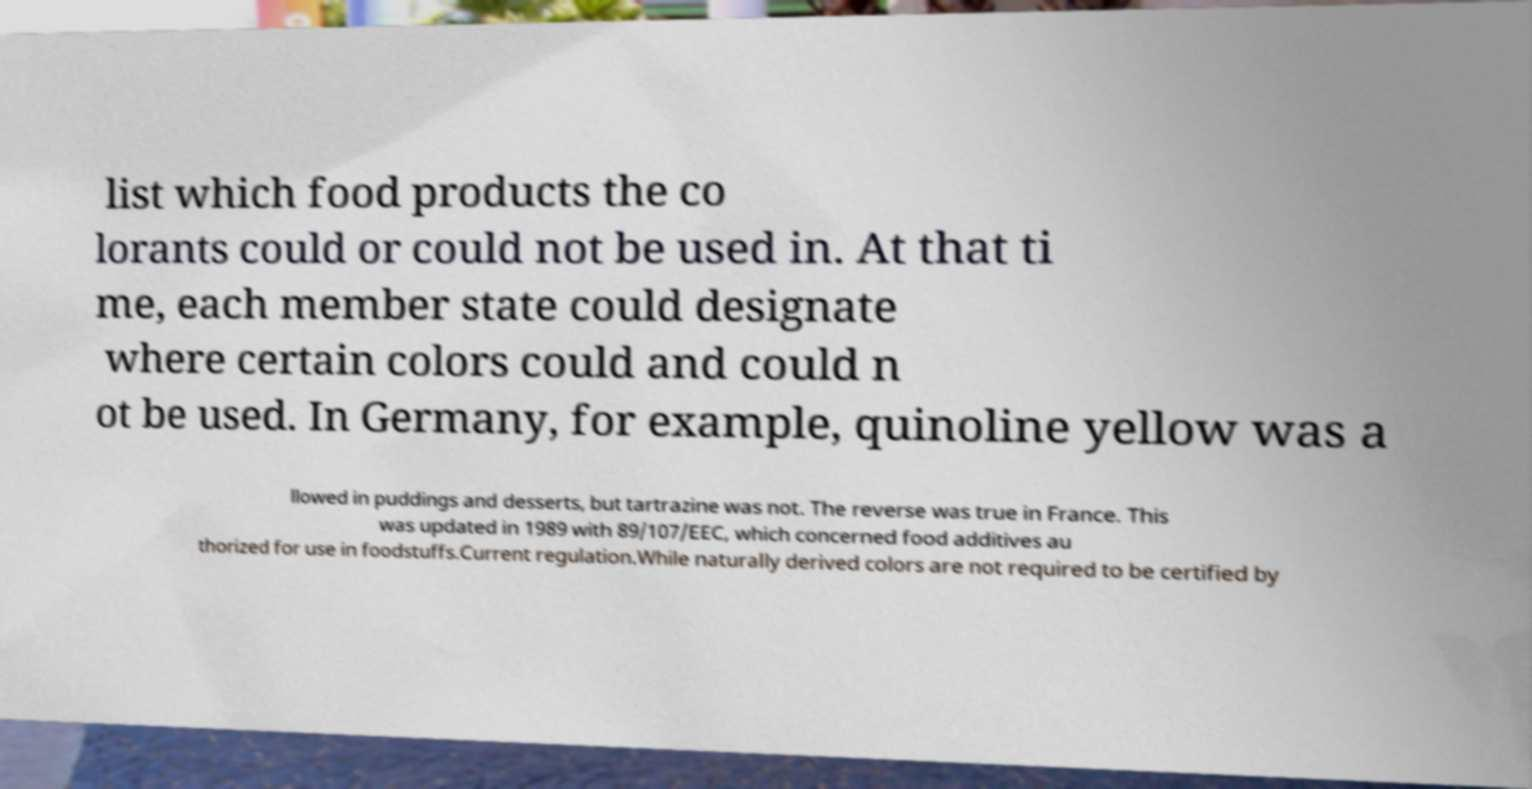There's text embedded in this image that I need extracted. Can you transcribe it verbatim? list which food products the co lorants could or could not be used in. At that ti me, each member state could designate where certain colors could and could n ot be used. In Germany, for example, quinoline yellow was a llowed in puddings and desserts, but tartrazine was not. The reverse was true in France. This was updated in 1989 with 89/107/EEC, which concerned food additives au thorized for use in foodstuffs.Current regulation.While naturally derived colors are not required to be certified by 